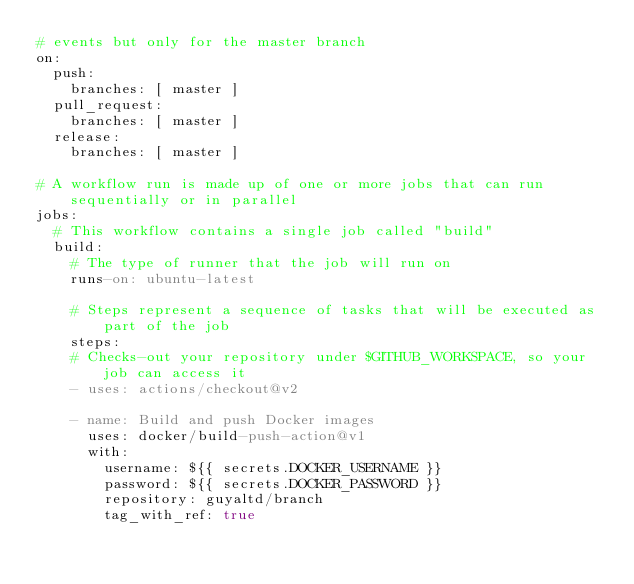<code> <loc_0><loc_0><loc_500><loc_500><_YAML_># events but only for the master branch
on:
  push:
    branches: [ master ]
  pull_request:
    branches: [ master ]
  release:
    branches: [ master ]

# A workflow run is made up of one or more jobs that can run sequentially or in parallel
jobs:
  # This workflow contains a single job called "build"
  build:
    # The type of runner that the job will run on
    runs-on: ubuntu-latest

    # Steps represent a sequence of tasks that will be executed as part of the job
    steps:
    # Checks-out your repository under $GITHUB_WORKSPACE, so your job can access it
    - uses: actions/checkout@v2
    
    - name: Build and push Docker images
      uses: docker/build-push-action@v1
      with:
        username: ${{ secrets.DOCKER_USERNAME }}
        password: ${{ secrets.DOCKER_PASSWORD }}
        repository: guyaltd/branch
        tag_with_ref: true
</code> 